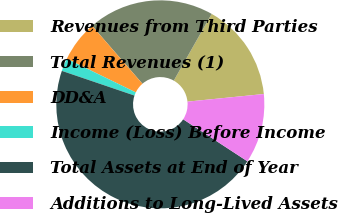Convert chart. <chart><loc_0><loc_0><loc_500><loc_500><pie_chart><fcel>Revenues from Third Parties<fcel>Total Revenues (1)<fcel>DD&A<fcel>Income (Loss) Before Income<fcel>Total Assets at End of Year<fcel>Additions to Long-Lived Assets<nl><fcel>15.2%<fcel>19.6%<fcel>6.4%<fcel>2.0%<fcel>46.0%<fcel>10.8%<nl></chart> 